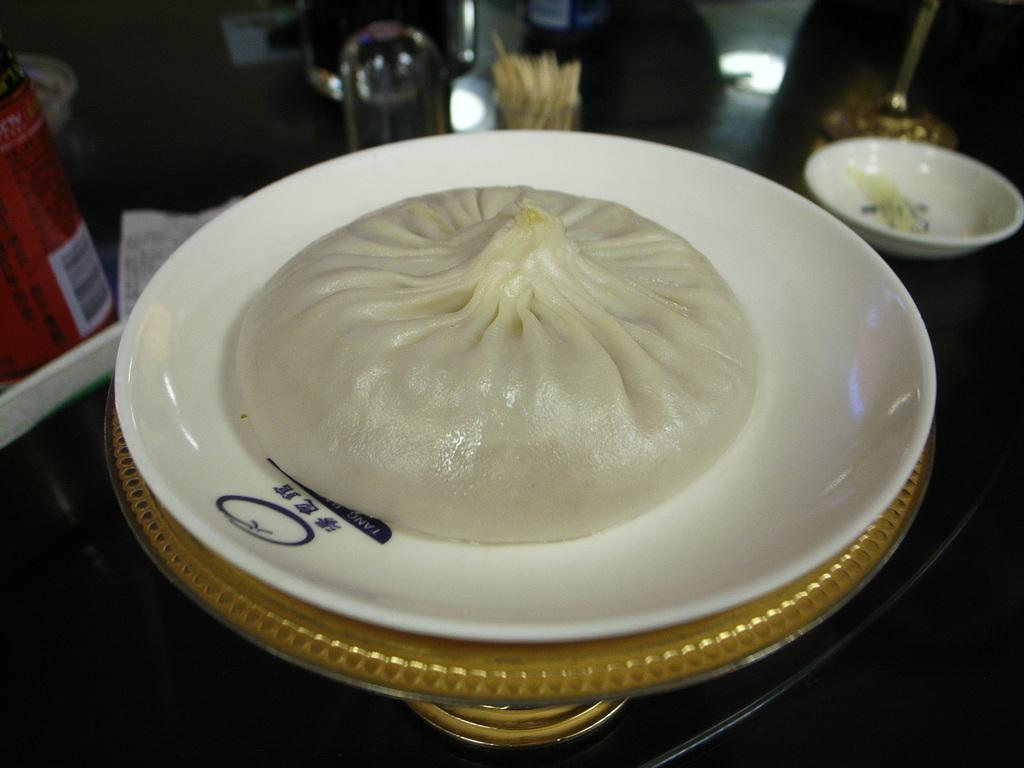What is on the plate that is visible in the image? The plate contains momos in the image. Where is the plate located in the image? The plate is placed on a table in the image. How many bikes are parked next to the table in the image? There are no bikes present in the image. What finger is used to eat the momos in the image? The image does not show anyone eating the momos, so it cannot be determined which finger would be used. 